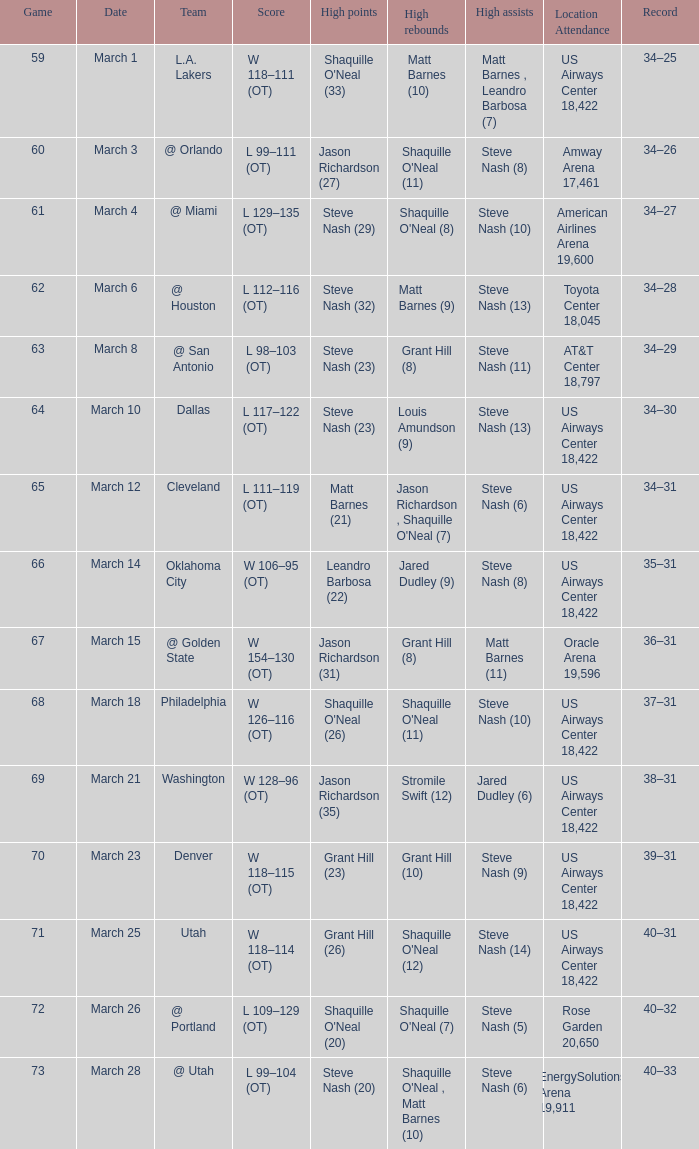After the March 15 game, what was the team's record? 36–31. 